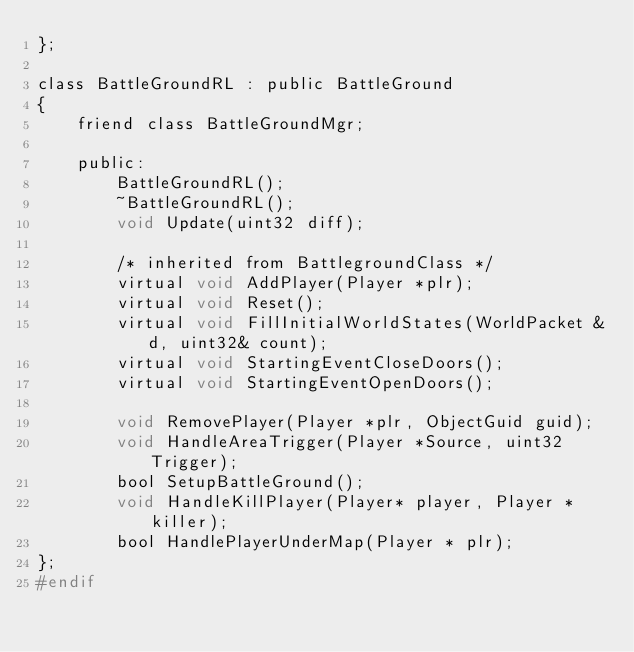Convert code to text. <code><loc_0><loc_0><loc_500><loc_500><_C_>};

class BattleGroundRL : public BattleGround
{
    friend class BattleGroundMgr;

    public:
        BattleGroundRL();
        ~BattleGroundRL();
        void Update(uint32 diff);

        /* inherited from BattlegroundClass */
        virtual void AddPlayer(Player *plr);
        virtual void Reset();
        virtual void FillInitialWorldStates(WorldPacket &d, uint32& count);
        virtual void StartingEventCloseDoors();
        virtual void StartingEventOpenDoors();

        void RemovePlayer(Player *plr, ObjectGuid guid);
        void HandleAreaTrigger(Player *Source, uint32 Trigger);
        bool SetupBattleGround();
        void HandleKillPlayer(Player* player, Player *killer);
        bool HandlePlayerUnderMap(Player * plr);
};
#endif
</code> 